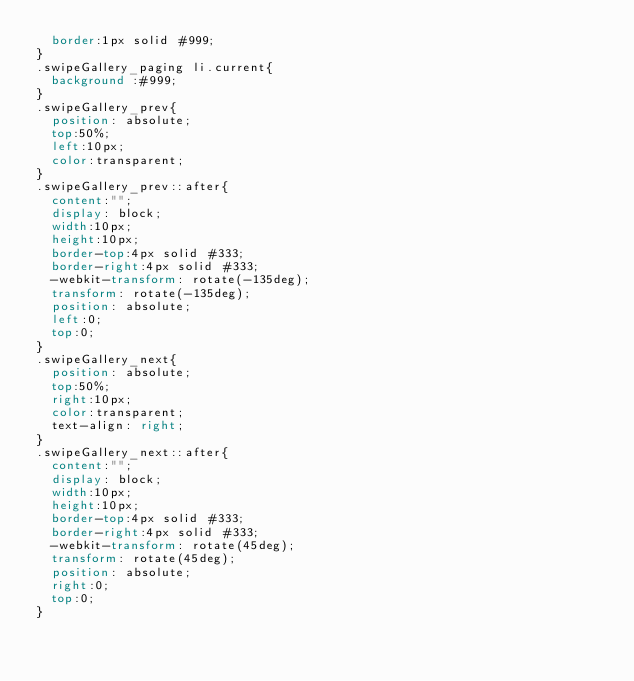<code> <loc_0><loc_0><loc_500><loc_500><_CSS_>	border:1px solid #999;
}
.swipeGallery_paging li.current{
	background :#999;
}
.swipeGallery_prev{
	position: absolute;
	top:50%;
	left:10px;
	color:transparent;
}
.swipeGallery_prev::after{
	content:"";
	display: block;
	width:10px;
	height:10px;
	border-top:4px solid #333;
	border-right:4px solid #333;
	-webkit-transform: rotate(-135deg);
	transform: rotate(-135deg);
	position: absolute;
	left:0;
	top:0;
}
.swipeGallery_next{
	position: absolute;
	top:50%;
	right:10px;
	color:transparent;
	text-align: right;
}
.swipeGallery_next::after{
	content:"";
	display: block;
	width:10px;
	height:10px;
	border-top:4px solid #333;
	border-right:4px solid #333;
	-webkit-transform: rotate(45deg);
	transform: rotate(45deg);
	position: absolute;
	right:0;
	top:0;
}</code> 